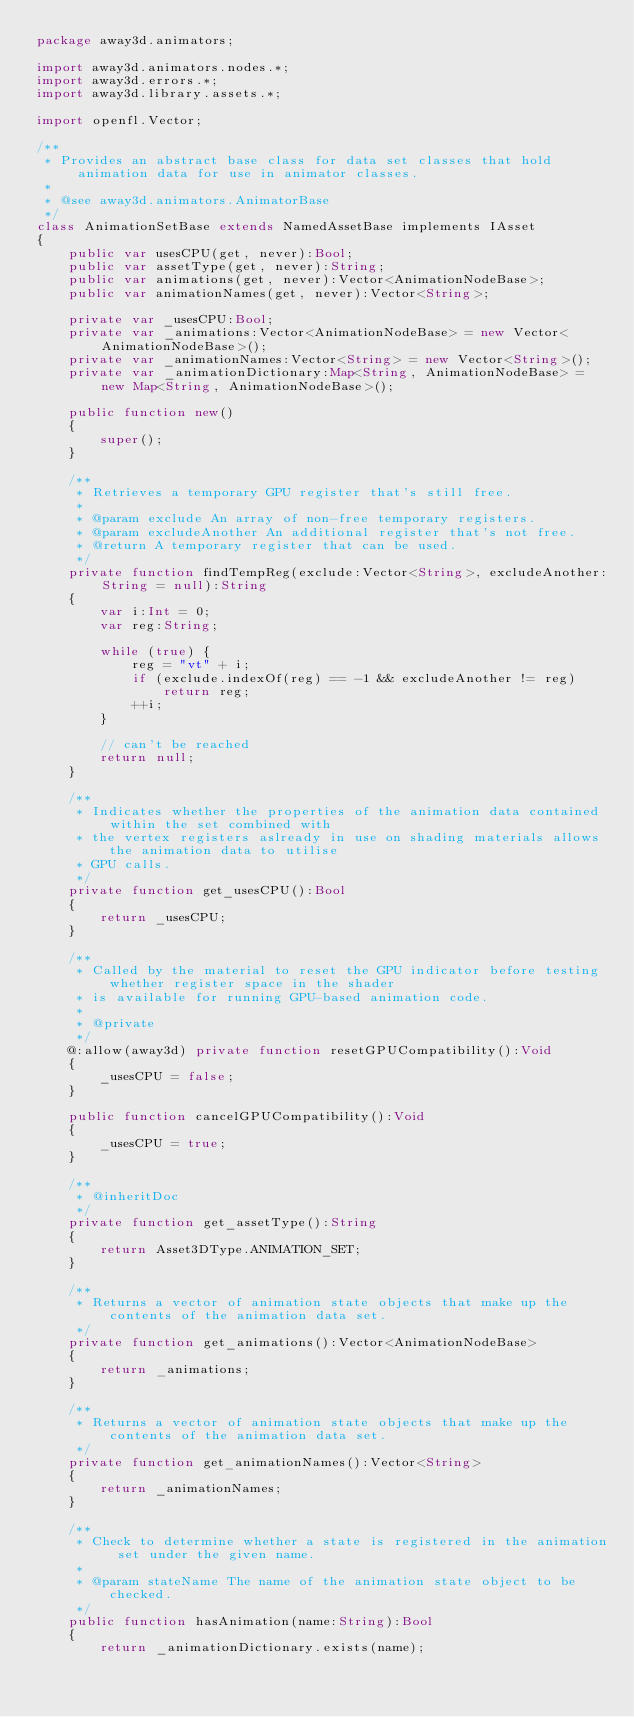<code> <loc_0><loc_0><loc_500><loc_500><_Haxe_>package away3d.animators;

import away3d.animators.nodes.*;
import away3d.errors.*;
import away3d.library.assets.*;

import openfl.Vector;

/**
 * Provides an abstract base class for data set classes that hold animation data for use in animator classes.
 *
 * @see away3d.animators.AnimatorBase
 */
class AnimationSetBase extends NamedAssetBase implements IAsset
{
	public var usesCPU(get, never):Bool;
	public var assetType(get, never):String;
	public var animations(get, never):Vector<AnimationNodeBase>;
	public var animationNames(get, never):Vector<String>;
	
	private var _usesCPU:Bool;
	private var _animations:Vector<AnimationNodeBase> = new Vector<AnimationNodeBase>();
	private var _animationNames:Vector<String> = new Vector<String>();
	private var _animationDictionary:Map<String, AnimationNodeBase> = new Map<String, AnimationNodeBase>();
	
	public function new()
	{
		super();
	}
	
	/**
	 * Retrieves a temporary GPU register that's still free.
	 *
	 * @param exclude An array of non-free temporary registers.
	 * @param excludeAnother An additional register that's not free.
	 * @return A temporary register that can be used.
	 */
	private function findTempReg(exclude:Vector<String>, excludeAnother:String = null):String
	{
		var i:Int = 0;
		var reg:String;
		
		while (true) {
			reg = "vt" + i;
			if (exclude.indexOf(reg) == -1 && excludeAnother != reg)
				return reg;
			++i;
		}
		
		// can't be reached
		return null;
	}
	
	/**
	 * Indicates whether the properties of the animation data contained within the set combined with
	 * the vertex registers aslready in use on shading materials allows the animation data to utilise
	 * GPU calls.
	 */
	private function get_usesCPU():Bool
	{
		return _usesCPU;
	}
	
	/**
	 * Called by the material to reset the GPU indicator before testing whether register space in the shader
	 * is available for running GPU-based animation code.
	 *
	 * @private
	 */
	@:allow(away3d) private function resetGPUCompatibility():Void
	{
		_usesCPU = false;
	}
	
	public function cancelGPUCompatibility():Void
	{
		_usesCPU = true;
	}
	
	/**
	 * @inheritDoc
	 */
	private function get_assetType():String
	{
		return Asset3DType.ANIMATION_SET;
	}
	
	/**
	 * Returns a vector of animation state objects that make up the contents of the animation data set.
	 */
	private function get_animations():Vector<AnimationNodeBase>
	{
		return _animations;
	}
	
	/**
	 * Returns a vector of animation state objects that make up the contents of the animation data set.
	 */
	private function get_animationNames():Vector<String>
	{
		return _animationNames;
	}
	
	/**
	 * Check to determine whether a state is registered in the animation set under the given name.
	 *
	 * @param stateName The name of the animation state object to be checked.
	 */
	public function hasAnimation(name:String):Bool
	{
		return _animationDictionary.exists(name);</code> 